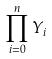<formula> <loc_0><loc_0><loc_500><loc_500>\prod _ { i = 0 } ^ { n } Y _ { i }</formula> 